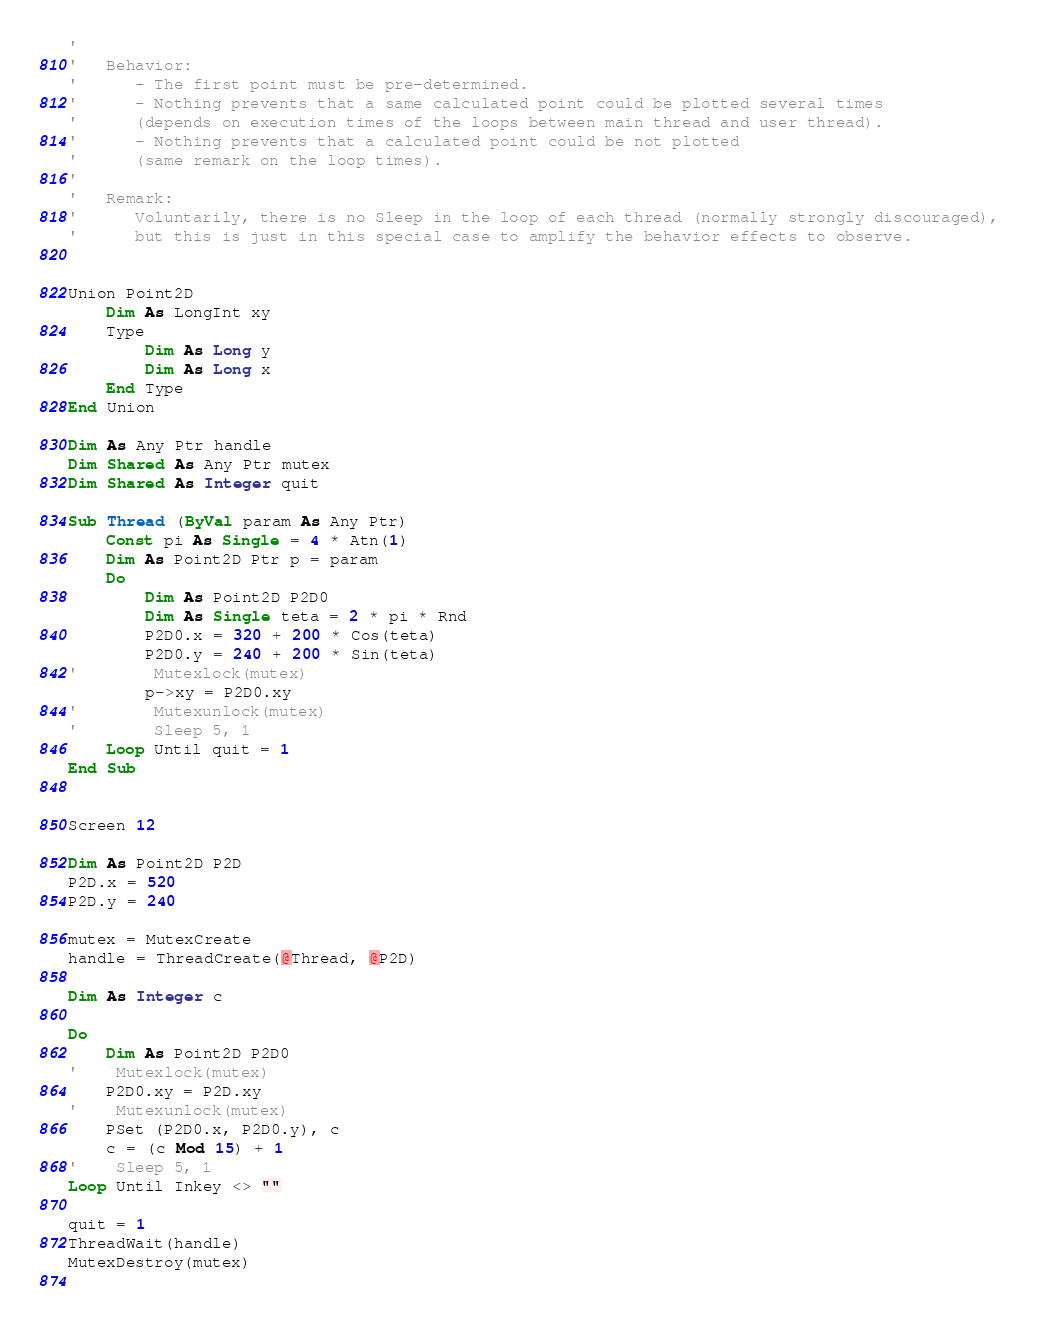<code> <loc_0><loc_0><loc_500><loc_500><_VisualBasic_>'
'   Behavior:
'      - The first point must be pre-determined.
'      - Nothing prevents that a same calculated point could be plotted several times
'      (depends on execution times of the loops between main thread and user thread).
'      - Nothing prevents that a calculated point could be not plotted
'      (same remark on the loop times).
'
'   Remark:
'      Voluntarily, there is no Sleep in the loop of each thread (normally strongly discouraged),
'      but this is just in this special case to amplify the behavior effects to observe.


Union Point2D
	Dim As LongInt xy
	Type
		Dim As Long y
		Dim As Long x
	End Type
End Union

Dim As Any Ptr handle
Dim Shared As Any Ptr mutex
Dim Shared As Integer quit

Sub Thread (ByVal param As Any Ptr)
	Const pi As Single = 4 * Atn(1)
	Dim As Point2D Ptr p = param
	Do
		Dim As Point2D P2D0
		Dim As Single teta = 2 * pi * Rnd
		P2D0.x = 320 + 200 * Cos(teta)
		P2D0.y = 240 + 200 * Sin(teta)
'        Mutexlock(mutex)
		p->xy = P2D0.xy
'        Mutexunlock(mutex)
'        Sleep 5, 1
	Loop Until quit = 1
End Sub


Screen 12

Dim As Point2D P2D
P2D.x = 520
P2D.y = 240

mutex = MutexCreate
handle = ThreadCreate(@Thread, @P2D)

Dim As Integer c

Do
	Dim As Point2D P2D0
'    Mutexlock(mutex)
	P2D0.xy = P2D.xy
'    Mutexunlock(mutex)
	PSet (P2D0.x, P2D0.y), c
	c = (c Mod 15) + 1
'    Sleep 5, 1
Loop Until Inkey <> ""
 
quit = 1
ThreadWait(handle)
MutexDestroy(mutex)
			
</code> 